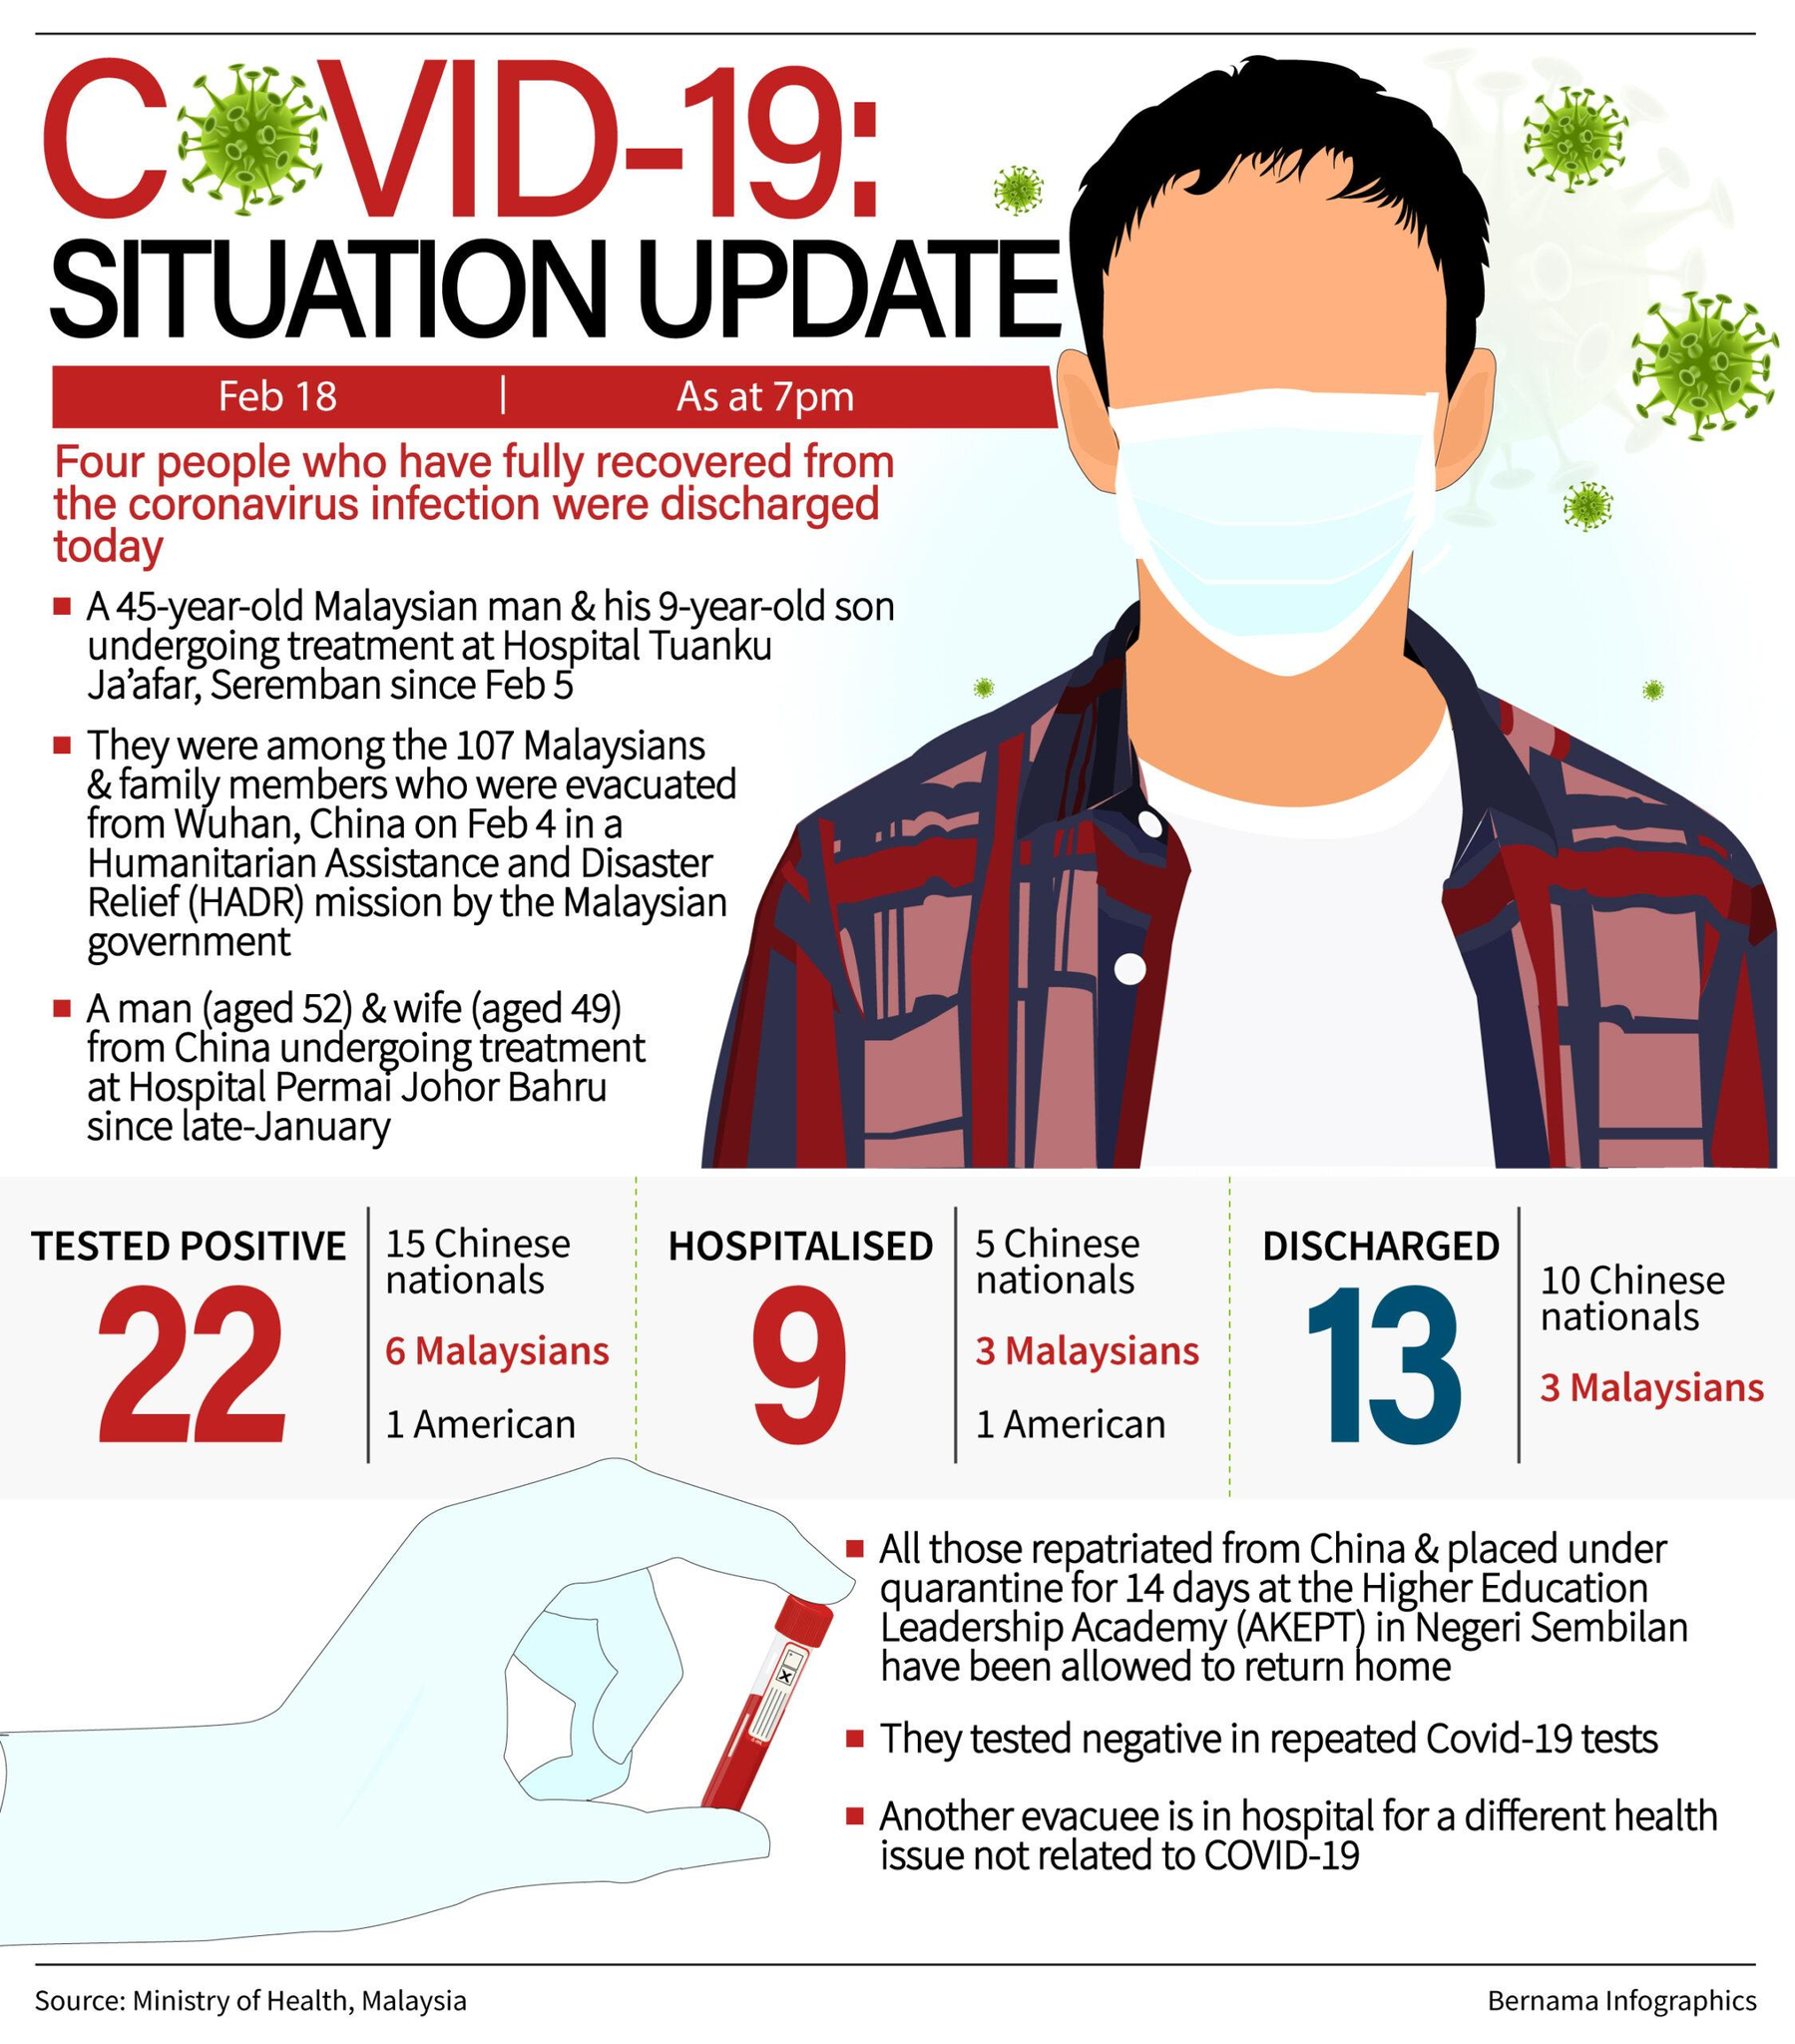Indicate a few pertinent items in this graphic. As of February 18, it is known that a total of 1 American was tested positive for COVID-19 in Malaysia. As of February 18, the total number of Covid-positive individuals hospitalized in Malaysia is 9,000. According to available information as of February 18, a total of 5 Chinese nationals were hospitalized in Malaysia. As of February 18th, it is known that 10 Chinese nationals were discharged from the hospital in Malaysia. 